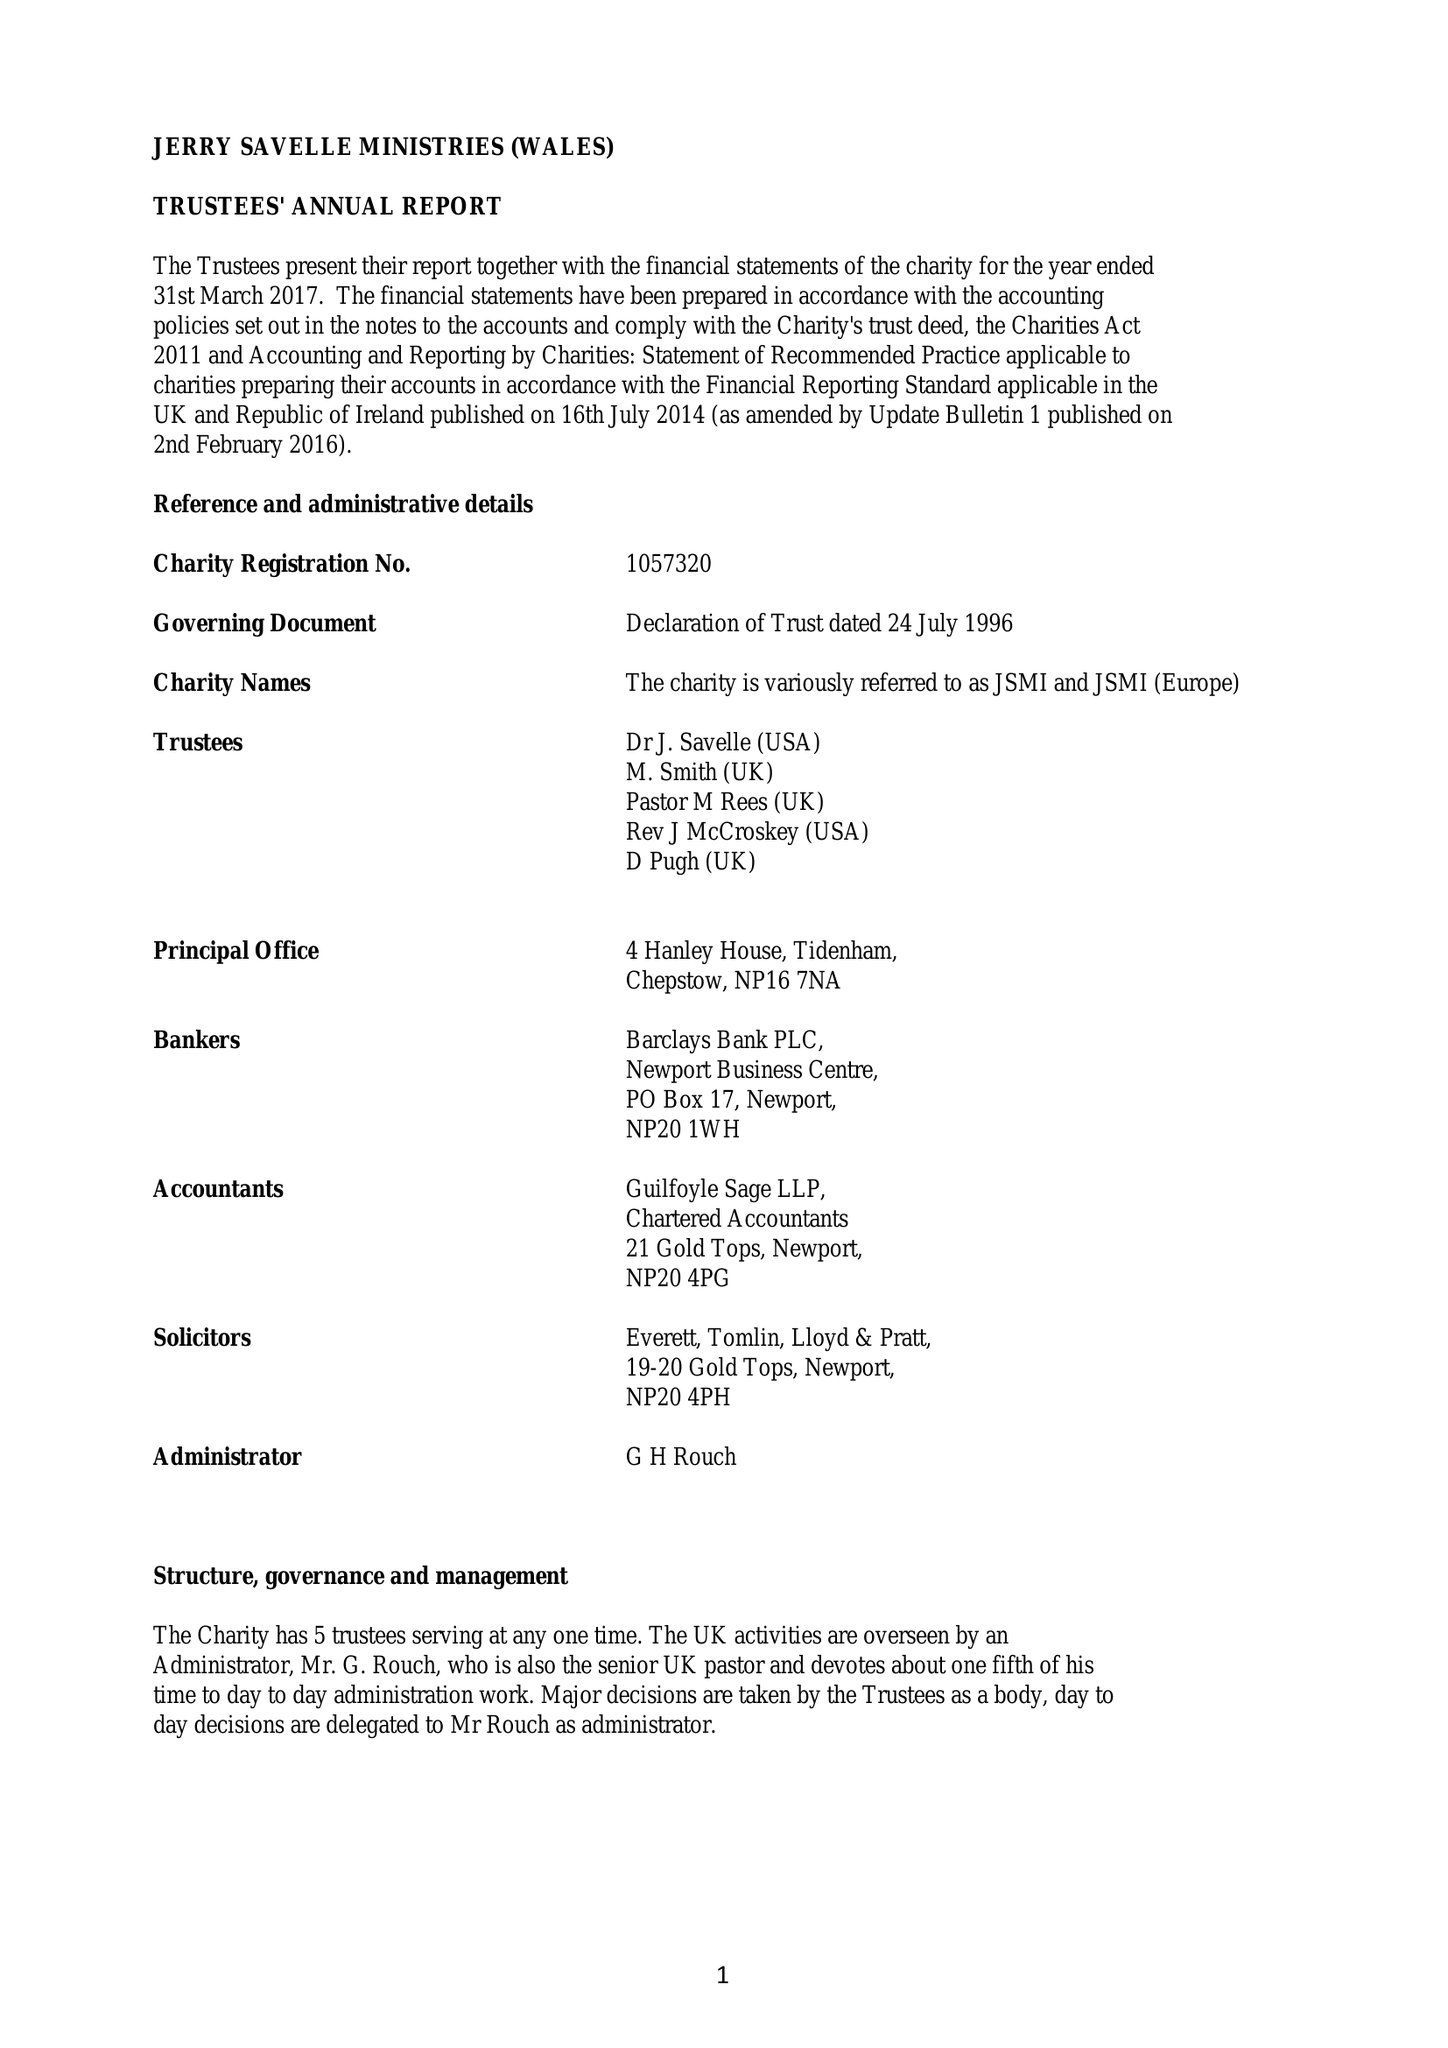What is the value for the report_date?
Answer the question using a single word or phrase. 2017-03-31 